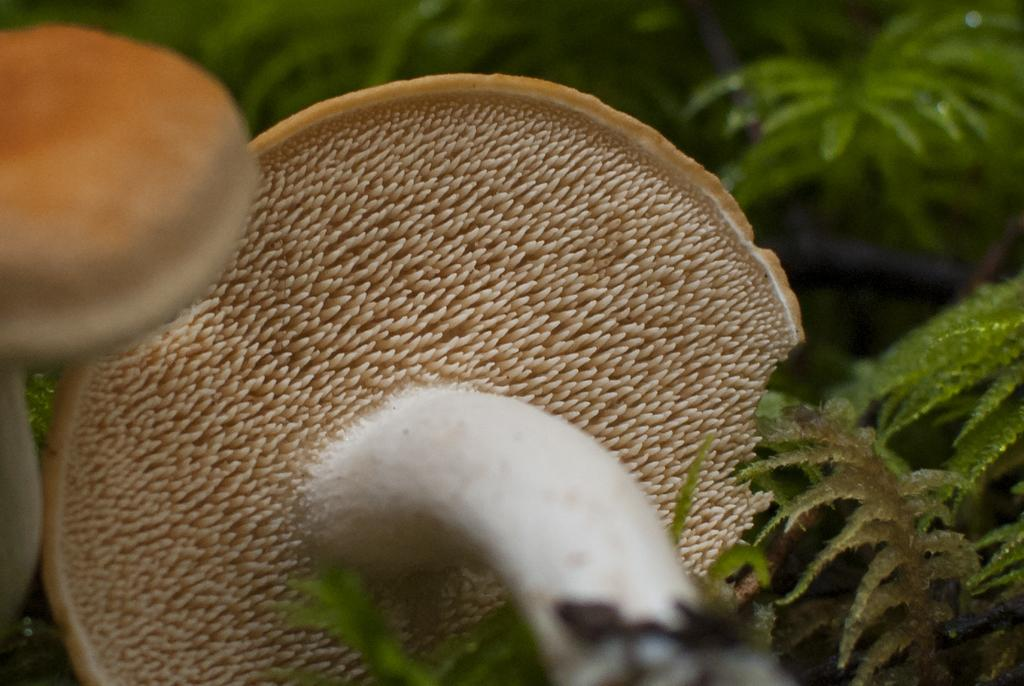What type of fungi can be seen in the image? There are mushrooms in the image. What colors are the mushrooms in the image? The mushrooms are in cream and white color. What type of vegetation is visible in the background of the image? There are plants in the background of the image. What color are the plants in the image? The plants are in green color. What sense does the mushroom possess in the image? Mushrooms do not possess senses like humans or animals; they are inanimate objects. --- 